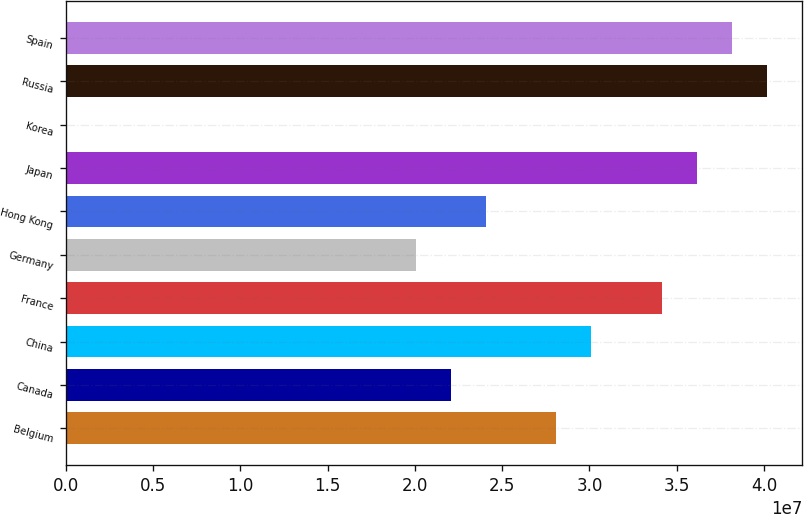Convert chart to OTSL. <chart><loc_0><loc_0><loc_500><loc_500><bar_chart><fcel>Belgium<fcel>Canada<fcel>China<fcel>France<fcel>Germany<fcel>Hong Kong<fcel>Japan<fcel>Korea<fcel>Russia<fcel>Spain<nl><fcel>2.8094e+07<fcel>2.2055e+07<fcel>3.0107e+07<fcel>3.4133e+07<fcel>2.0042e+07<fcel>2.4068e+07<fcel>3.6146e+07<fcel>2014<fcel>4.0172e+07<fcel>3.8159e+07<nl></chart> 